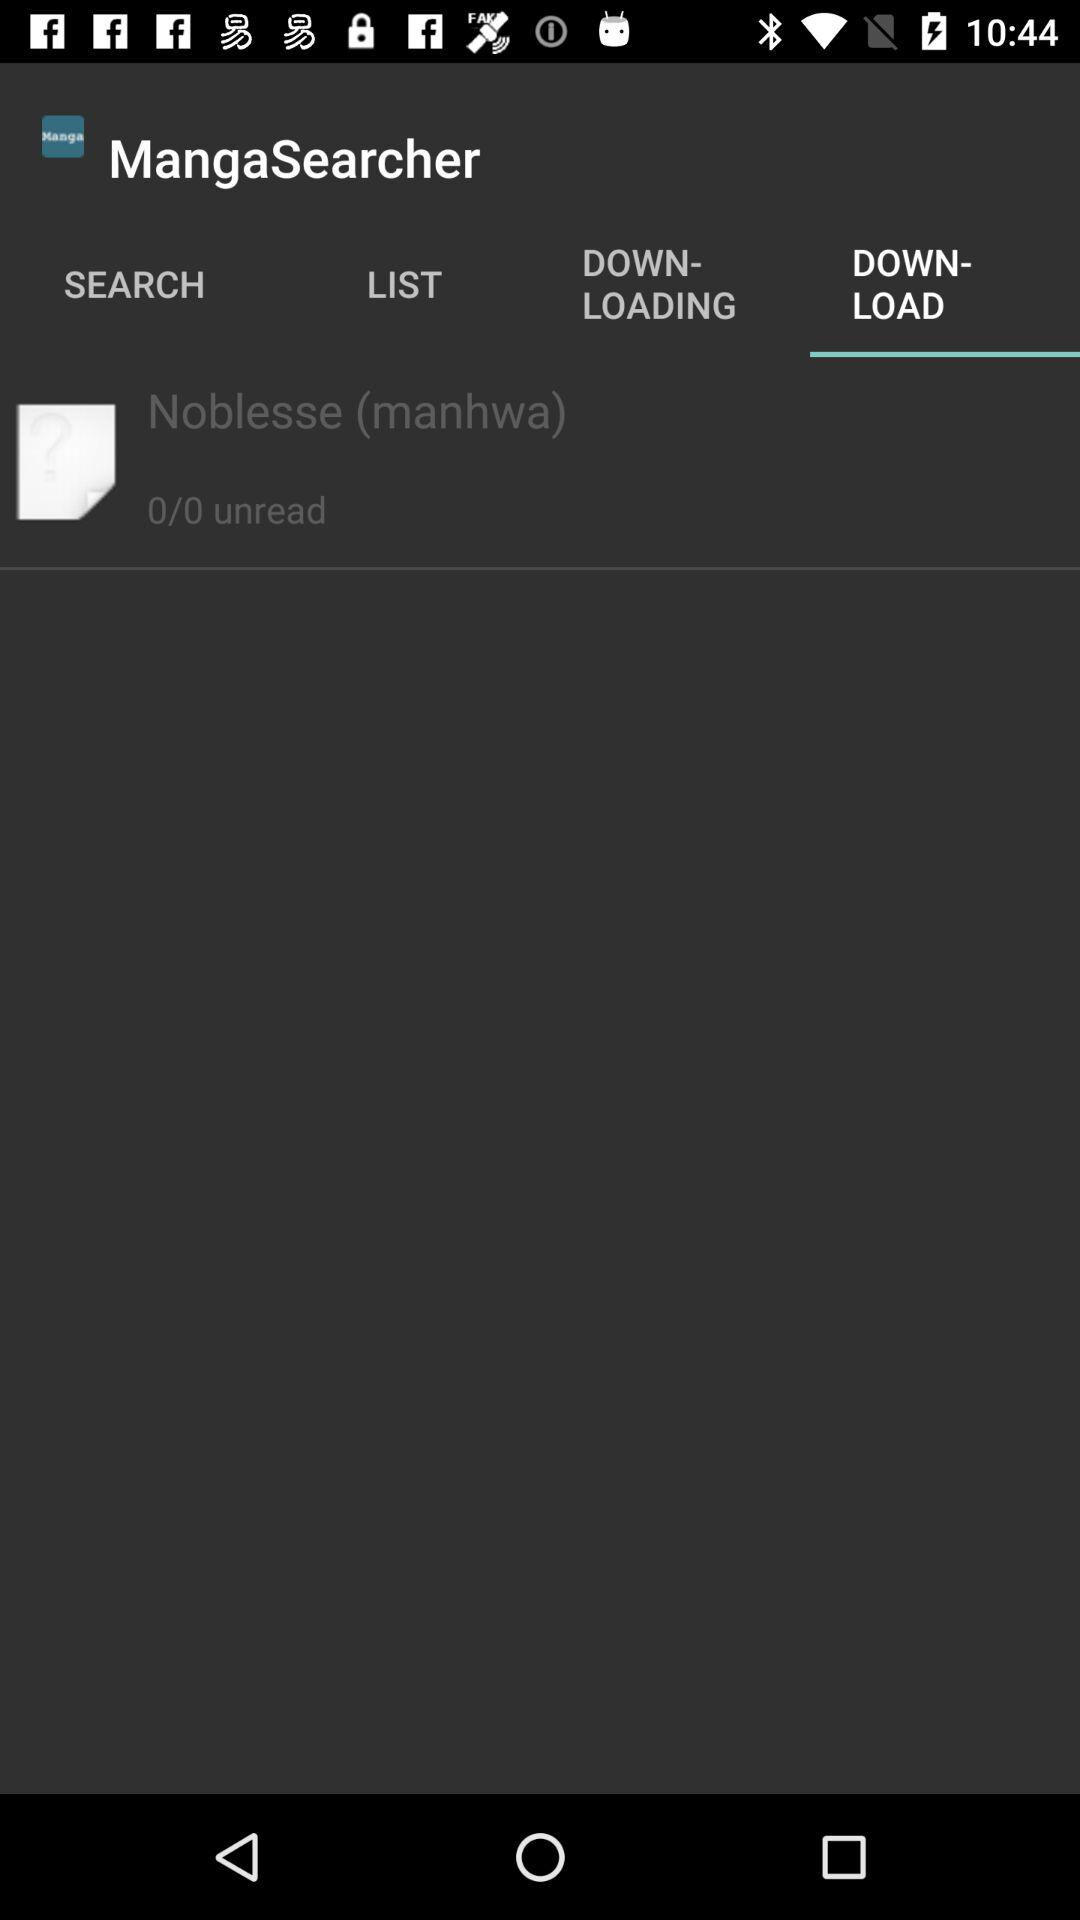How many unread items are there?
Answer the question using a single word or phrase. 0 